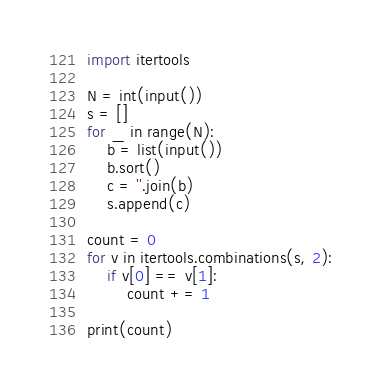<code> <loc_0><loc_0><loc_500><loc_500><_Python_>import itertools

N = int(input())
s = []
for _ in range(N):
    b = list(input())
    b.sort()
    c = ''.join(b)
    s.append(c)

count = 0
for v in itertools.combinations(s, 2):
    if v[0] == v[1]:
        count += 1

print(count)</code> 